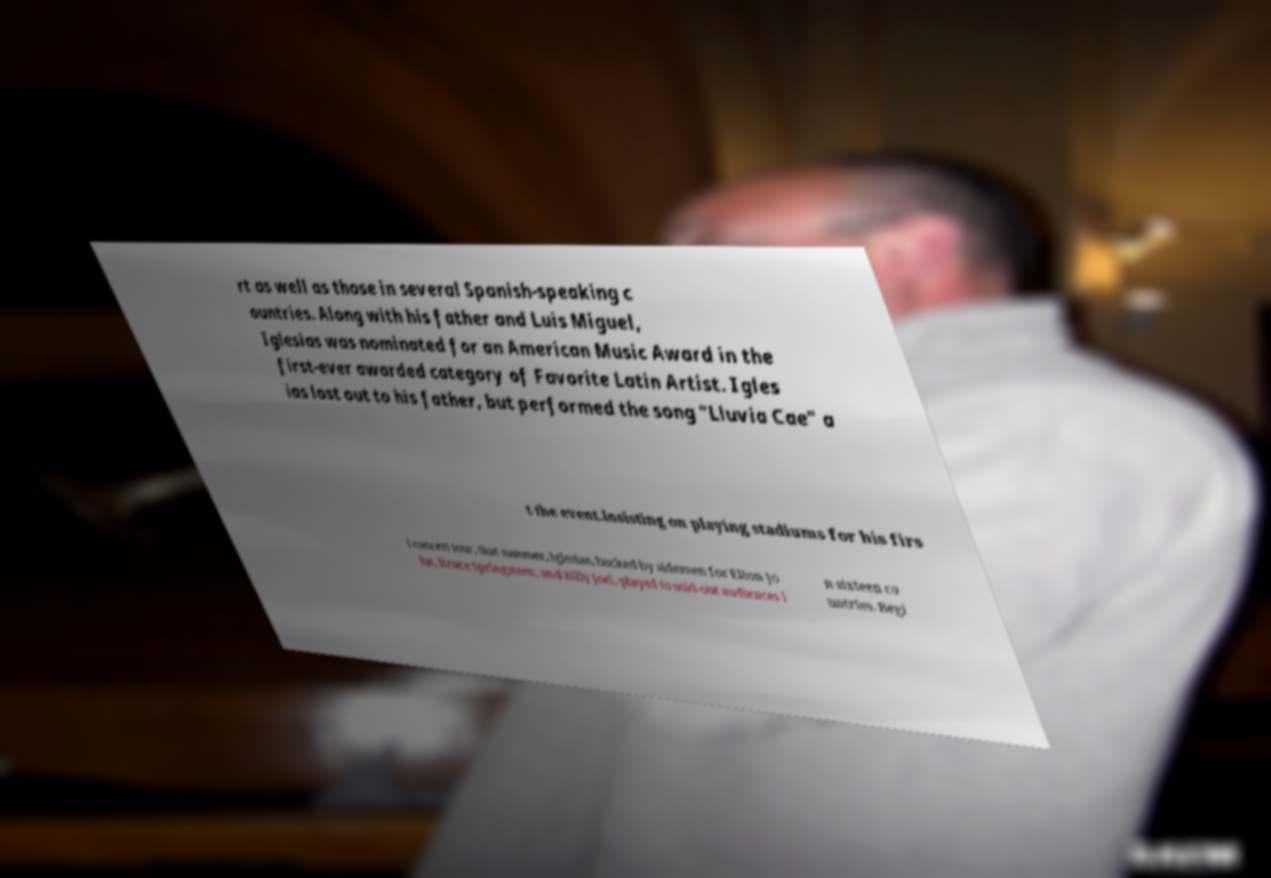Could you assist in decoding the text presented in this image and type it out clearly? rt as well as those in several Spanish-speaking c ountries. Along with his father and Luis Miguel, Iglesias was nominated for an American Music Award in the first-ever awarded category of Favorite Latin Artist. Igles ias lost out to his father, but performed the song "Lluvia Cae" a t the event.Insisting on playing stadiums for his firs t concert tour, that summer, Iglesias, backed by sidemen for Elton Jo hn, Bruce Springsteen, and Billy Joel, played to sold-out audiences i n sixteen co untries. Begi 